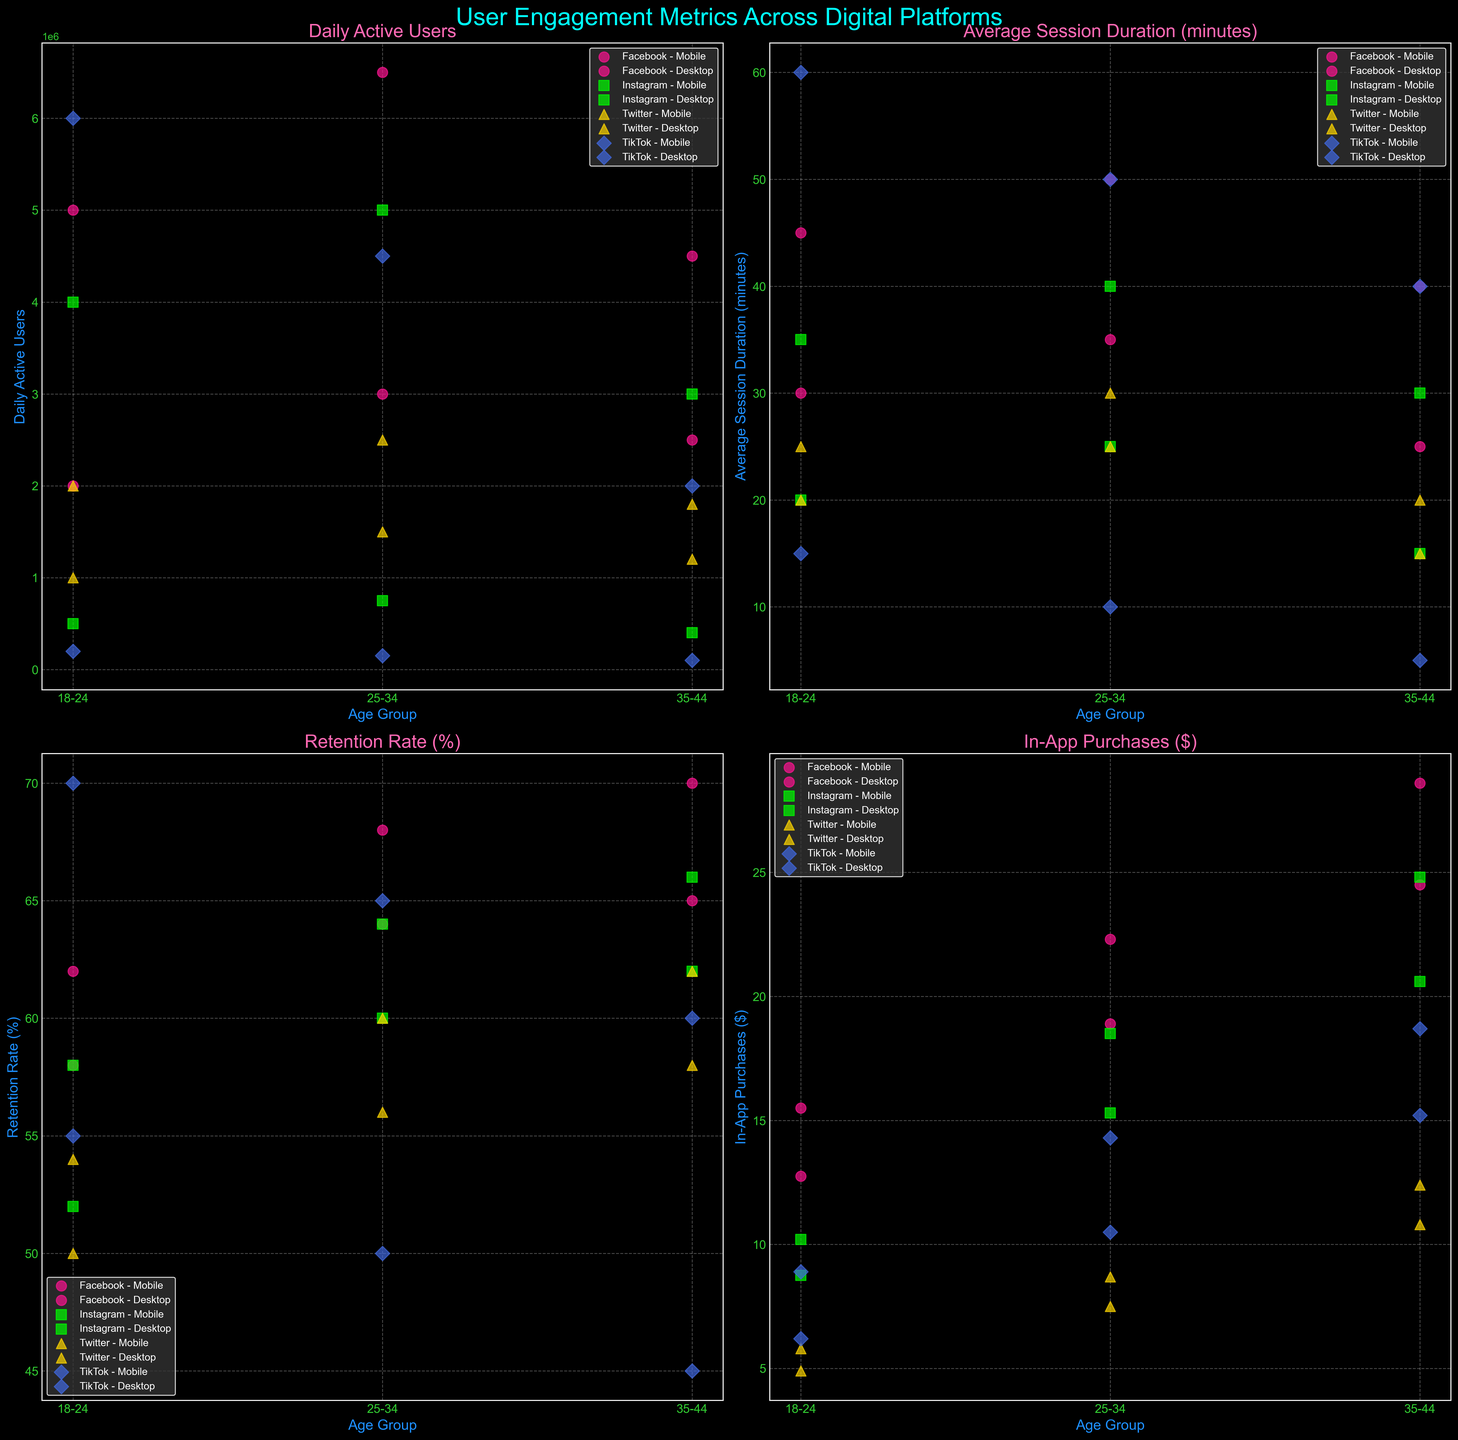What are the titles of the subplots? The titles of the subplots are displayed at the top of each individual plot in the grid. They are: 'Daily Active Users', 'Average Session Duration (minutes)', 'Retention Rate (%)', and 'In-App Purchases ($)'.
Answer: 'Daily Active Users', 'Average Session Duration (minutes)', 'Retention Rate (%)', 'In-App Purchases ($)' Which platform and device type combination has the highest Daily Active Users in the age group 18-24? Looking at the 'Daily Active Users' subplot, the platform and device with the highest Daily Active Users in the age group 18-24 is TikTok on Mobile.
Answer: TikTok on Mobile Among the age group 35-44, which device type generally shows longer Average Session Duration across platforms? In the 'Average Session Duration (minutes)' subplot, for the age group 35-44, Mobile devices generally show longer session durations compared to Desktop devices across all platforms like Facebook, Instagram, Twitter, and TikTok.
Answer: Mobile Which platform has the highest Retention Rate (%) for Mobile users in the age group 25-34? Reviewing the 'Retention Rate (%)' subplot, for Mobile users in the age group 25-34, Facebook has the highest retention rate.
Answer: Facebook Among the platforms, which one shows the lowest average In-App Purchases ($) for Desktop users in the age group 25-34? Checking the 'In-App Purchases ($)' subplot, TikTok on Desktop for the age group 25-34 shows the lowest In-App Purchases ($) among platforms.
Answer: TikTok Compare the Daily Active Users on Mobile between Instagram and Twitter for the age group 25-34. In the 'Daily Active Users' subplot, for age group 25-34, Instagram Mobile has higher Daily Active Users compared to Twitter Mobile. Instagram Mobile shows 5,000,000 whereas Twitter Mobile shows 2,500,000.
Answer: Instagram has higher Daily Active Users How does the Retention Rate (%) change across all age groups for Mobile users on Facebook? Observing the 'Retention Rate (%)' subplot for Facebook Mobile across all age groups: 62% (18-24), 68% (25-34), and 70% (35-44), we notice that the retention rate increases as the age group increases for Mobile users on Facebook.
Answer: Retention Rate increases Which platform-device combination has the lowest Average Session Duration (minutes) for age group 35-44? In the 'Average Session Duration (minutes)' subplot, the platform and device combination with the lowest session duration for age group 35-44 is TikTok on Desktop.
Answer: TikTok on Desktop Which age group has the highest In-App Purchases ($) on Mobile across all platforms? Looking at the 'In-App Purchases ($)' subplot, the age group 35-44 on Mobile across all platforms generally has the highest In-App Purchases ($) with values like 28.6 (Facebook), 24.8 (Instagram), and 18.7 (TikTok).
Answer: 35-44 Does the Desktop device show higher Retention Rate (%) than Mobile devices for Twitter in the age group 25-34? In the 'Retention Rate (%)' subplot, for Twitter in the age group 25-34, Mobile has a retention rate of 60% while Desktop has 56%. Therefore, Mobile devices show a higher Retention Rate than Desktop.
Answer: No 